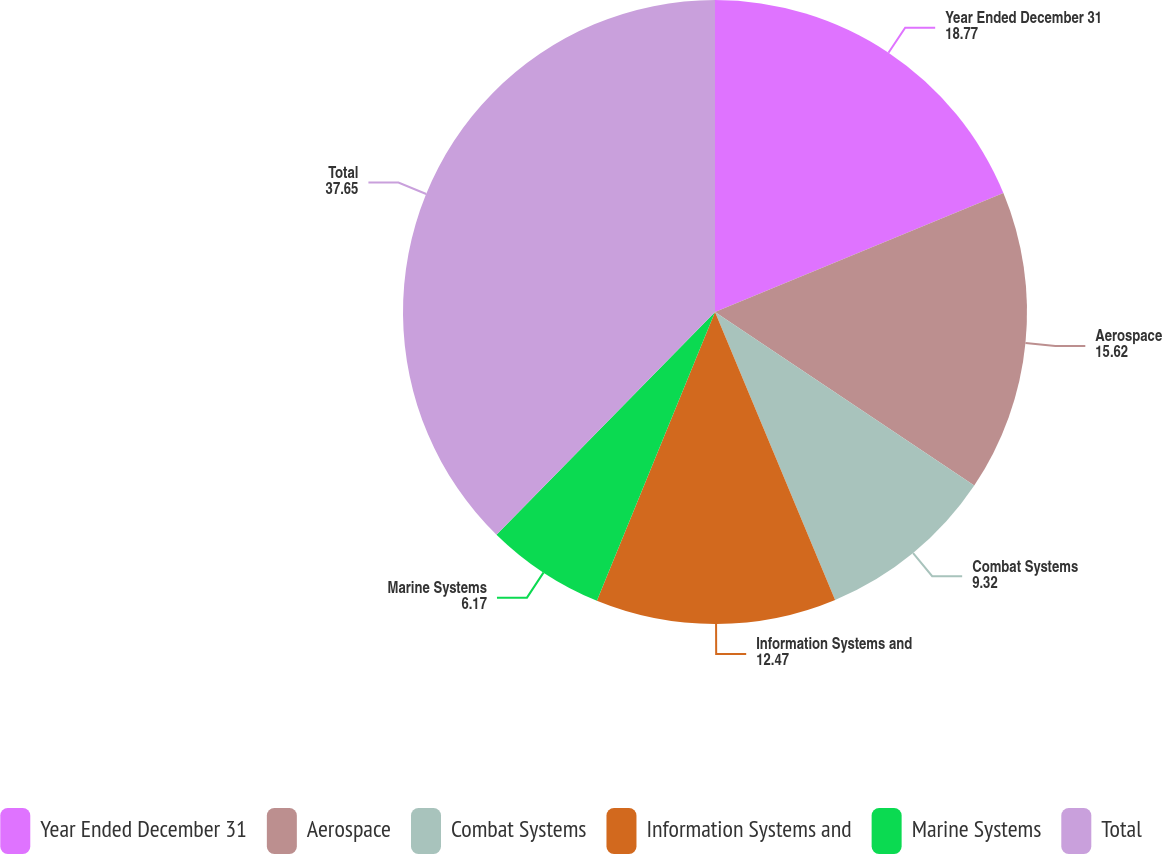Convert chart. <chart><loc_0><loc_0><loc_500><loc_500><pie_chart><fcel>Year Ended December 31<fcel>Aerospace<fcel>Combat Systems<fcel>Information Systems and<fcel>Marine Systems<fcel>Total<nl><fcel>18.77%<fcel>15.62%<fcel>9.32%<fcel>12.47%<fcel>6.17%<fcel>37.65%<nl></chart> 